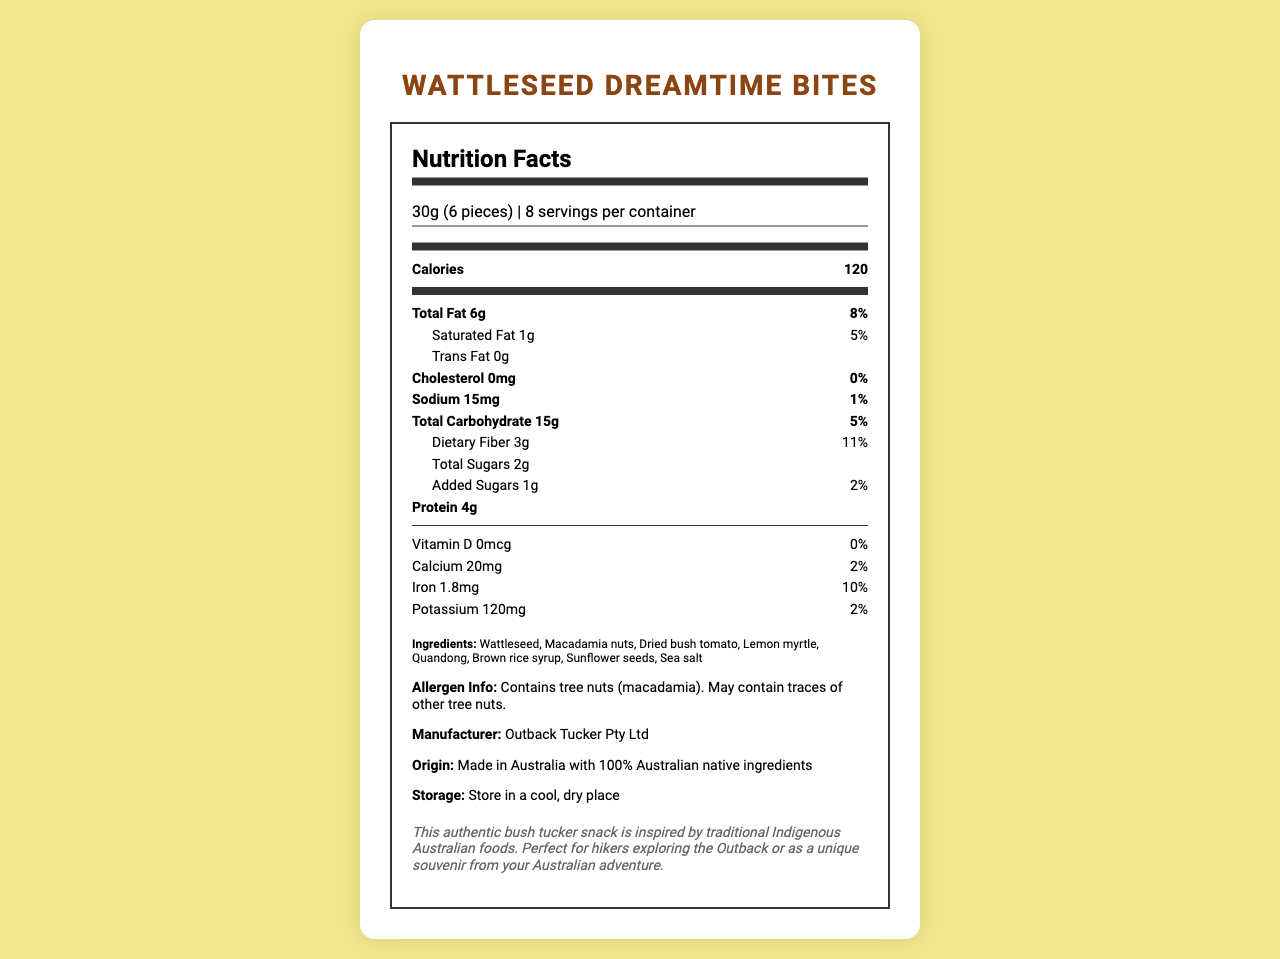who is the manufacturer of Wattleseed Dreamtime Bites? The manufacturer information is clearly stated in the document as "Outback Tucker Pty Ltd".
Answer: Outback Tucker Pty Ltd how many servings are there per container? The document states that there are "8 servings per container".
Answer: 8 servings what is the serving size of Wattleseed Dreamtime Bites? The serving size is explicitly mentioned as "30g (6 pieces)".
Answer: 30g (6 pieces) how many calories are in one serving? The nutrition label indicates that each serving contains 120 calories.
Answer: 120 calories how much protein is in each serving? The nutrition label shows that there are 4 grams of protein per serving.
Answer: 4g what are the main ingredients in Wattleseed Dreamtime Bites? A. Almonds, Pumpkin seeds, Bush tomato B. Wattleseed, Macadamia nuts, Quandong C. Honey, Oats, Chia seeds D. Banana, Coconut, Lemon myrtle The document lists the ingredients as Wattleseed, Macadamia nuts, Dried bush tomato, Lemon myrtle, Quandong, Brown rice syrup, Sunflower seeds, Sea salt.
Answer: B how much total fat is in each serving? The nutrition label indicates that each serving contains 6 grams of total fat.
Answer: 6g what percentage of daily value is the saturated fat in one serving? A. 2% B. 5% C. 8% D. 11% The document states that the saturated fat is 1g which is 5% of the daily value.
Answer: B is there any cholesterol in Wattleseed Dreamtime Bites? The nutrition label shows that the cholesterol amount is 0mg (0% daily value), indicating there is no cholesterol.
Answer: No are there any allergens in this product? The allergen info states that the product contains tree nuts (macadamia).
Answer: Yes can we determine the price of the product from this document? The document does not provide any information regarding the price of the product.
Answer: No which nutrient has the highest percentage of daily value in one serving? The document indicates that dietary fiber has the highest percentage of daily value at 11%.
Answer: Dietary fiber how much sodium is in one serving? The nutrition label states that there are 15mg of sodium per serving.
Answer: 15mg how many grams of dietary fiber are in each serving? The nutrition label indicates that each serving has 3 grams of dietary fiber.
Answer: 3g is this product made with 100% Australian native ingredients? The document states that the product is "Made in Australia with 100% Australian native ingredients".
Answer: Yes summarize the main information provided in the document The document is an all-encompassing nutrition label with information about servings, nutrients, ingredients, allergens, manufacturer, origin, storage, and product background.
Answer: The document provides detailed nutrition facts for Wattleseed Dreamtime Bites, a bush tucker snack made by Outback Tucker Pty Ltd. Key information includes serving size (30g/6 pieces), number of servings per container (8), and nutritional content including calories (120), total fat (6g), and protein (4g). It also lists ingredients, allergen information, manufacturer, origin, storage instructions, and some additional context about the product's inspiration from traditional Indigenous Australian foods. 